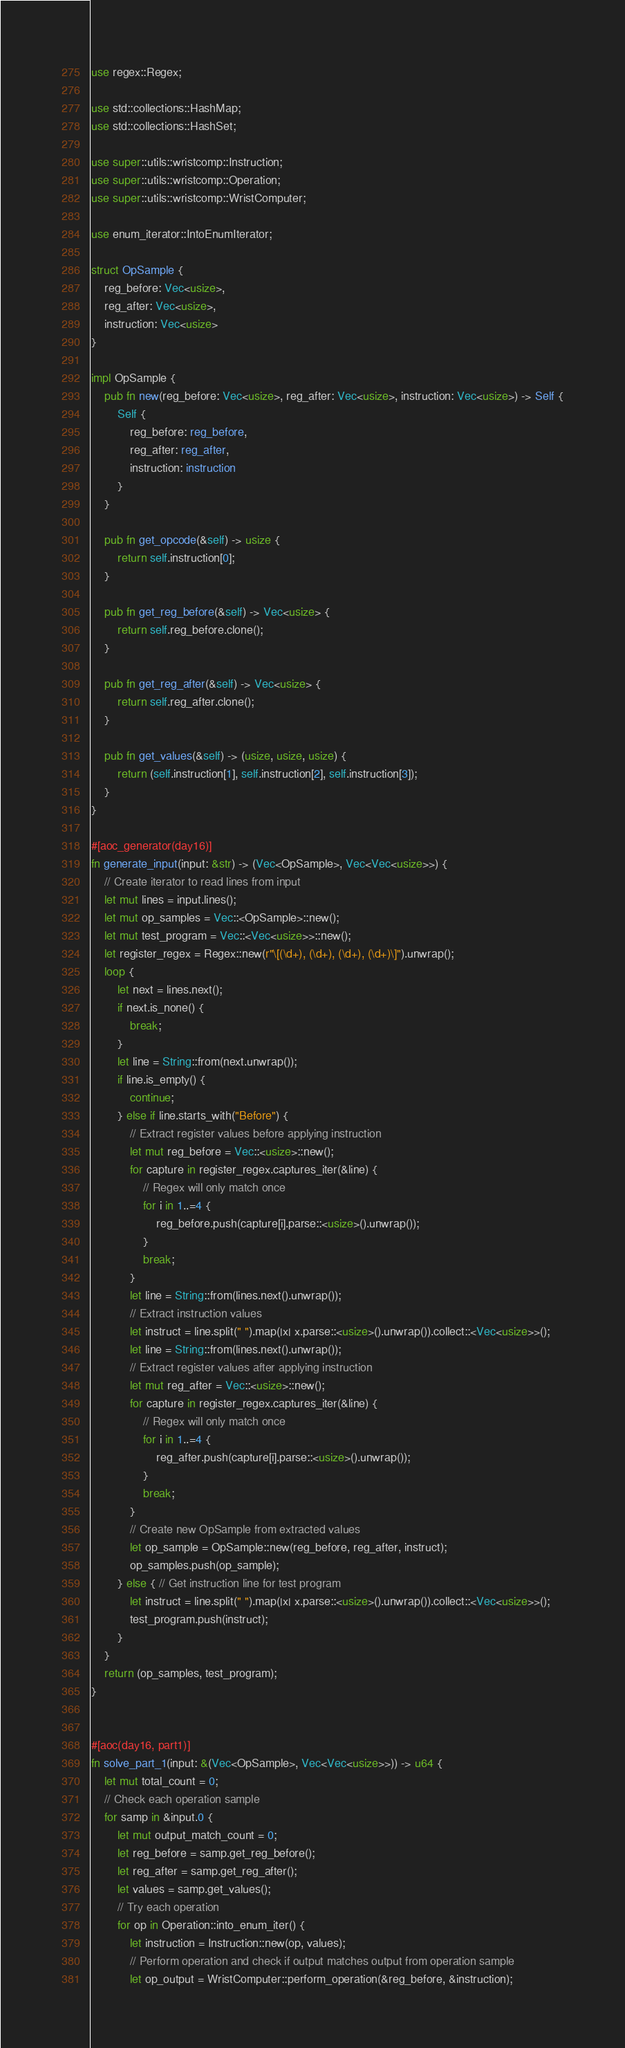Convert code to text. <code><loc_0><loc_0><loc_500><loc_500><_Rust_>use regex::Regex;

use std::collections::HashMap;
use std::collections::HashSet;

use super::utils::wristcomp::Instruction;
use super::utils::wristcomp::Operation;
use super::utils::wristcomp::WristComputer;

use enum_iterator::IntoEnumIterator;

struct OpSample {
    reg_before: Vec<usize>,
    reg_after: Vec<usize>,
    instruction: Vec<usize>
}

impl OpSample {
    pub fn new(reg_before: Vec<usize>, reg_after: Vec<usize>, instruction: Vec<usize>) -> Self {
        Self {
            reg_before: reg_before,
            reg_after: reg_after,
            instruction: instruction
        }
    }

    pub fn get_opcode(&self) -> usize {
        return self.instruction[0];
    }

    pub fn get_reg_before(&self) -> Vec<usize> {
        return self.reg_before.clone();
    }
    
    pub fn get_reg_after(&self) -> Vec<usize> {
        return self.reg_after.clone();
    }

    pub fn get_values(&self) -> (usize, usize, usize) {
        return (self.instruction[1], self.instruction[2], self.instruction[3]);
    }
}

#[aoc_generator(day16)]
fn generate_input(input: &str) -> (Vec<OpSample>, Vec<Vec<usize>>) {
    // Create iterator to read lines from input
    let mut lines = input.lines();
    let mut op_samples = Vec::<OpSample>::new();
    let mut test_program = Vec::<Vec<usize>>::new();
    let register_regex = Regex::new(r"\[(\d+), (\d+), (\d+), (\d+)\]").unwrap();
    loop {
        let next = lines.next();
        if next.is_none() {
            break;
        }
        let line = String::from(next.unwrap());
        if line.is_empty() {
            continue;
        } else if line.starts_with("Before") {
            // Extract register values before applying instruction
            let mut reg_before = Vec::<usize>::new();
            for capture in register_regex.captures_iter(&line) {
                // Regex will only match once
                for i in 1..=4 {
                    reg_before.push(capture[i].parse::<usize>().unwrap());
                }
                break;
            }
            let line = String::from(lines.next().unwrap());
            // Extract instruction values
            let instruct = line.split(" ").map(|x| x.parse::<usize>().unwrap()).collect::<Vec<usize>>();
            let line = String::from(lines.next().unwrap());
            // Extract register values after applying instruction
            let mut reg_after = Vec::<usize>::new();
            for capture in register_regex.captures_iter(&line) {
                // Regex will only match once
                for i in 1..=4 {
                    reg_after.push(capture[i].parse::<usize>().unwrap());
                }
                break;
            }
            // Create new OpSample from extracted values
            let op_sample = OpSample::new(reg_before, reg_after, instruct);
            op_samples.push(op_sample);
        } else { // Get instruction line for test program
            let instruct = line.split(" ").map(|x| x.parse::<usize>().unwrap()).collect::<Vec<usize>>();
            test_program.push(instruct);
        }
    }
    return (op_samples, test_program);
}


#[aoc(day16, part1)]
fn solve_part_1(input: &(Vec<OpSample>, Vec<Vec<usize>>)) -> u64 {
    let mut total_count = 0;
    // Check each operation sample
    for samp in &input.0 {
        let mut output_match_count = 0;
        let reg_before = samp.get_reg_before();
        let reg_after = samp.get_reg_after();
        let values = samp.get_values();
        // Try each operation
        for op in Operation::into_enum_iter() {
            let instruction = Instruction::new(op, values);
            // Perform operation and check if output matches output from operation sample
            let op_output = WristComputer::perform_operation(&reg_before, &instruction);</code> 